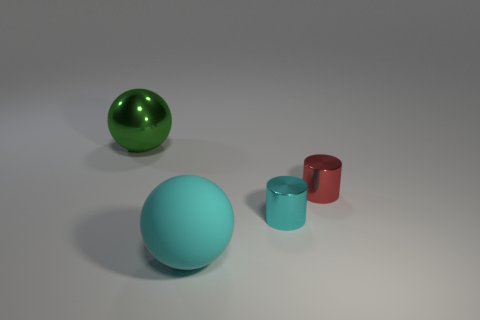What is the shape of the red object that is the same size as the cyan shiny cylinder? The red object that shares the same size as the cyan shiny cylinder is also a cylinder. It has a smooth, curved surface and a circular base, consistent with the characteristics of cylindrical objects. 